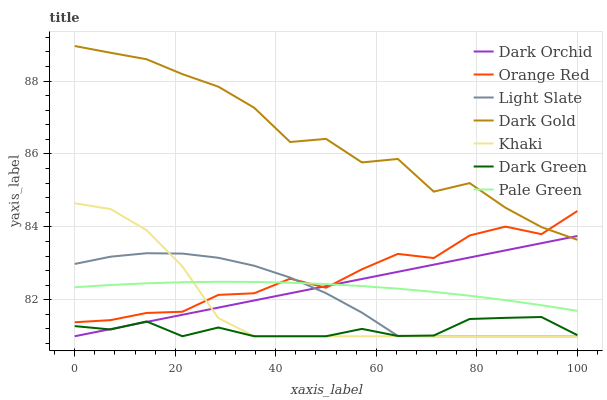Does Dark Green have the minimum area under the curve?
Answer yes or no. Yes. Does Dark Gold have the maximum area under the curve?
Answer yes or no. Yes. Does Light Slate have the minimum area under the curve?
Answer yes or no. No. Does Light Slate have the maximum area under the curve?
Answer yes or no. No. Is Dark Orchid the smoothest?
Answer yes or no. Yes. Is Dark Gold the roughest?
Answer yes or no. Yes. Is Light Slate the smoothest?
Answer yes or no. No. Is Light Slate the roughest?
Answer yes or no. No. Does Dark Gold have the lowest value?
Answer yes or no. No. Does Dark Gold have the highest value?
Answer yes or no. Yes. Does Light Slate have the highest value?
Answer yes or no. No. Is Light Slate less than Dark Gold?
Answer yes or no. Yes. Is Dark Gold greater than Dark Green?
Answer yes or no. Yes. Does Pale Green intersect Orange Red?
Answer yes or no. Yes. Is Pale Green less than Orange Red?
Answer yes or no. No. Is Pale Green greater than Orange Red?
Answer yes or no. No. Does Light Slate intersect Dark Gold?
Answer yes or no. No. 